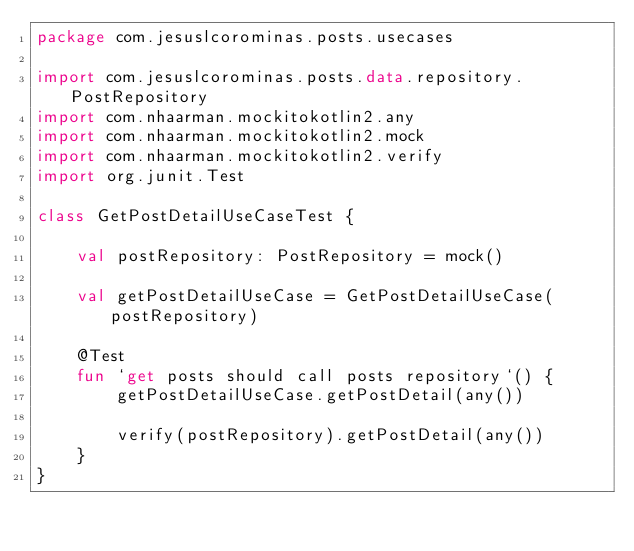<code> <loc_0><loc_0><loc_500><loc_500><_Kotlin_>package com.jesuslcorominas.posts.usecases

import com.jesuslcorominas.posts.data.repository.PostRepository
import com.nhaarman.mockitokotlin2.any
import com.nhaarman.mockitokotlin2.mock
import com.nhaarman.mockitokotlin2.verify
import org.junit.Test

class GetPostDetailUseCaseTest {

    val postRepository: PostRepository = mock()

    val getPostDetailUseCase = GetPostDetailUseCase(postRepository)

    @Test
    fun `get posts should call posts repository`() {
        getPostDetailUseCase.getPostDetail(any())

        verify(postRepository).getPostDetail(any())
    }
}</code> 